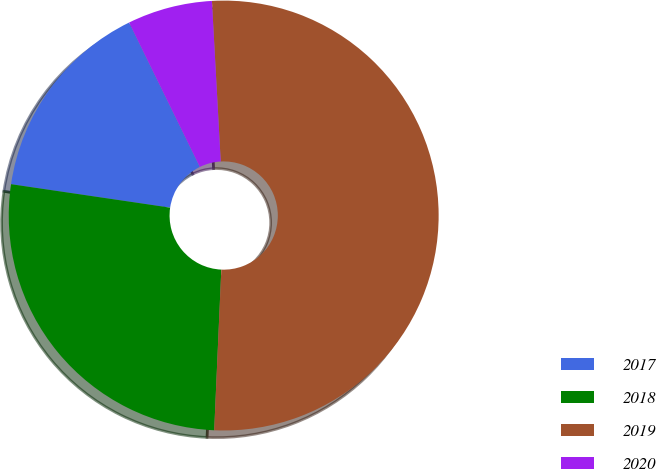<chart> <loc_0><loc_0><loc_500><loc_500><pie_chart><fcel>2017<fcel>2018<fcel>2019<fcel>2020<nl><fcel>15.42%<fcel>26.63%<fcel>51.58%<fcel>6.38%<nl></chart> 